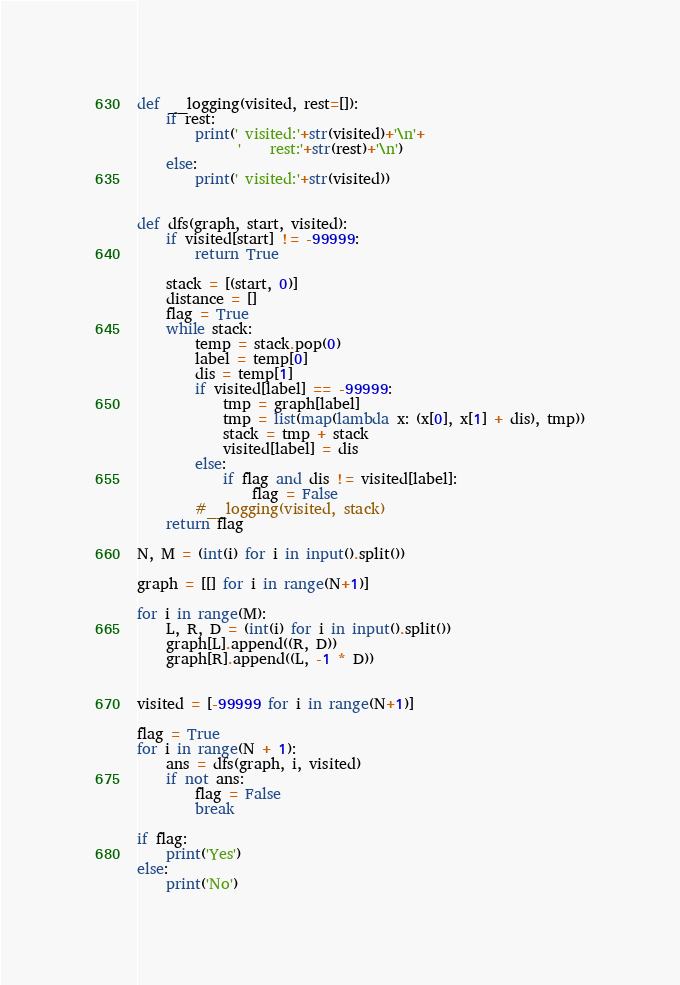<code> <loc_0><loc_0><loc_500><loc_500><_Python_>def __logging(visited, rest=[]):
    if rest:
        print(' visited:'+str(visited)+'\n'+
              '    rest:'+str(rest)+'\n')
    else:
        print(' visited:'+str(visited))


def dfs(graph, start, visited):
    if visited[start] != -99999:
        return True
    
    stack = [(start, 0)]
    distance = []
    flag = True
    while stack:
        temp = stack.pop(0)
        label = temp[0]
        dis = temp[1]
        if visited[label] == -99999:
            tmp = graph[label]
            tmp = list(map(lambda x: (x[0], x[1] + dis), tmp))
            stack = tmp + stack
            visited[label] = dis
        else:
            if flag and dis != visited[label]:
                flag = False
        #__logging(visited, stack)
    return flag

N, M = (int(i) for i in input().split())  

graph = [[] for i in range(N+1)]

for i in range(M):
    L, R, D = (int(i) for i in input().split())
    graph[L].append((R, D))
    graph[R].append((L, -1 * D))


visited = [-99999 for i in range(N+1)]

flag = True
for i in range(N + 1):
    ans = dfs(graph, i, visited)
    if not ans:
        flag = False
        break

if flag:
    print('Yes')
else:
    print('No')
</code> 